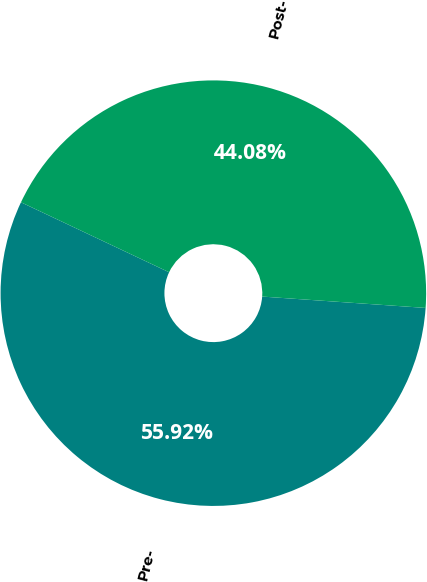Convert chart. <chart><loc_0><loc_0><loc_500><loc_500><pie_chart><fcel>Pre-<fcel>Post-<nl><fcel>55.92%<fcel>44.08%<nl></chart> 